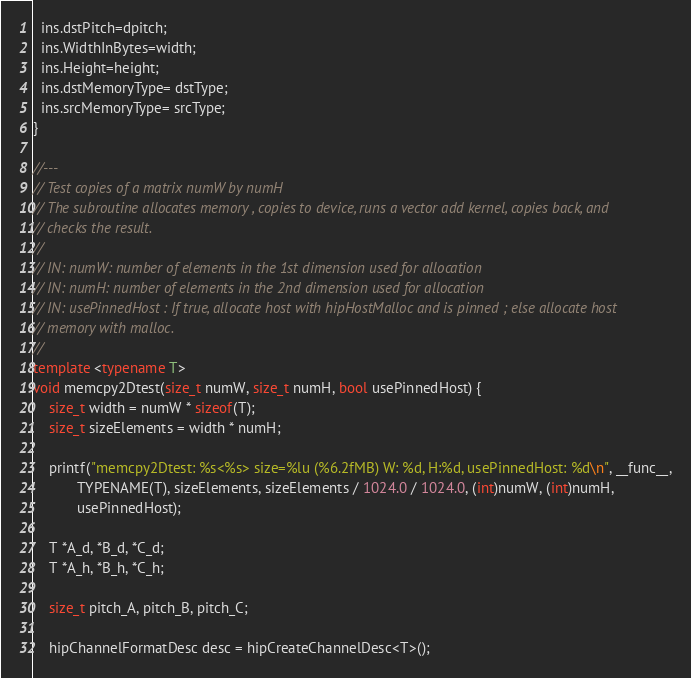<code> <loc_0><loc_0><loc_500><loc_500><_C++_>  ins.dstPitch=dpitch;
  ins.WidthInBytes=width;
  ins.Height=height;
  ins.dstMemoryType= dstType;
  ins.srcMemoryType= srcType;
}

//---
// Test copies of a matrix numW by numH
// The subroutine allocates memory , copies to device, runs a vector add kernel, copies back, and
// checks the result.
//
// IN: numW: number of elements in the 1st dimension used for allocation
// IN: numH: number of elements in the 2nd dimension used for allocation
// IN: usePinnedHost : If true, allocate host with hipHostMalloc and is pinned ; else allocate host
// memory with malloc.
//
template <typename T>
void memcpy2Dtest(size_t numW, size_t numH, bool usePinnedHost) {
    size_t width = numW * sizeof(T);
    size_t sizeElements = width * numH;

    printf("memcpy2Dtest: %s<%s> size=%lu (%6.2fMB) W: %d, H:%d, usePinnedHost: %d\n", __func__,
           TYPENAME(T), sizeElements, sizeElements / 1024.0 / 1024.0, (int)numW, (int)numH,
           usePinnedHost);

    T *A_d, *B_d, *C_d;
    T *A_h, *B_h, *C_h;

    size_t pitch_A, pitch_B, pitch_C;

    hipChannelFormatDesc desc = hipCreateChannelDesc<T>();</code> 